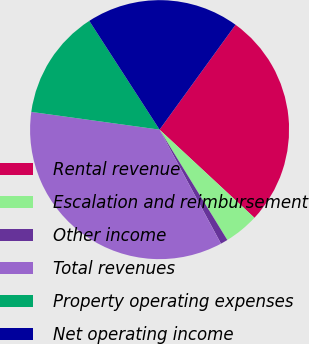Convert chart. <chart><loc_0><loc_0><loc_500><loc_500><pie_chart><fcel>Rental revenue<fcel>Escalation and reimbursement<fcel>Other income<fcel>Total revenues<fcel>Property operating expenses<fcel>Net operating income<nl><fcel>26.94%<fcel>4.32%<fcel>0.9%<fcel>35.05%<fcel>13.68%<fcel>19.11%<nl></chart> 